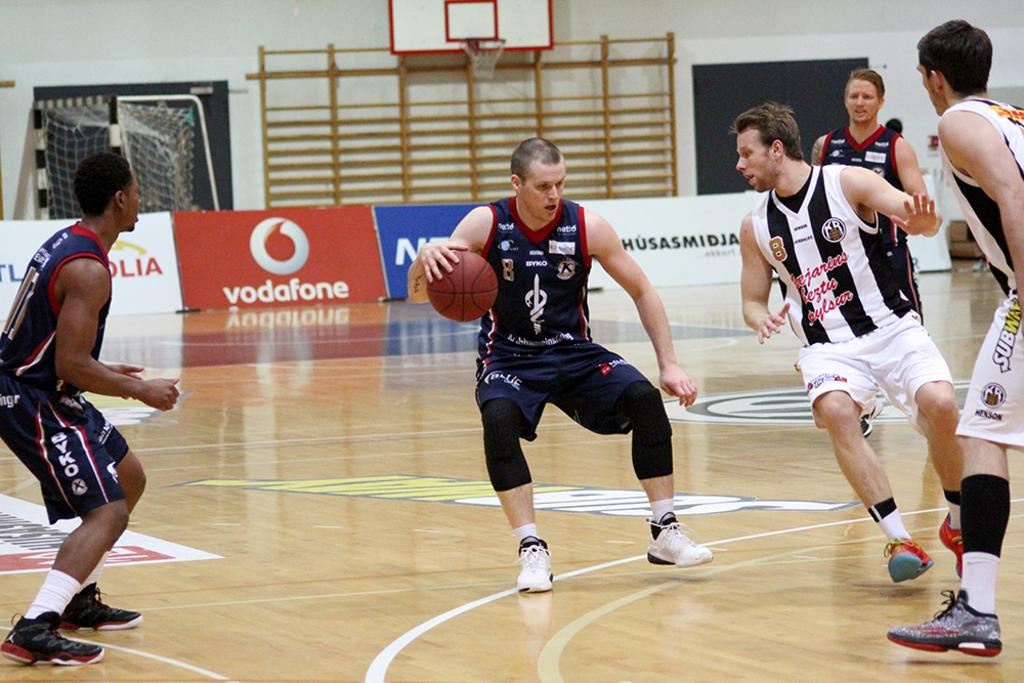<image>
Provide a brief description of the given image. A basketball game is underway and the court has a sign that says vodafone. 